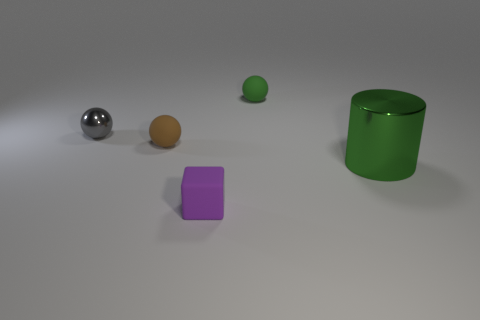There is a tiny matte ball that is behind the metal sphere; does it have the same color as the metallic object right of the small purple matte cube?
Keep it short and to the point. Yes. How many big green cylinders are in front of the small matte object in front of the big green metal object?
Your response must be concise. 0. How many rubber things are either blue cylinders or tiny cubes?
Ensure brevity in your answer.  1. Is there a small brown ball that has the same material as the block?
Offer a terse response. Yes. How many objects are either things behind the tiny cube or metal objects that are to the left of the tiny green matte thing?
Ensure brevity in your answer.  4. Is the color of the tiny rubber sphere that is behind the tiny brown rubber thing the same as the large metal thing?
Offer a very short reply. Yes. How many other things are there of the same color as the metal cylinder?
Provide a succinct answer. 1. What is the small gray ball made of?
Give a very brief answer. Metal. Is the size of the rubber sphere in front of the gray object the same as the tiny green object?
Offer a terse response. Yes. Is there any other thing that is the same size as the brown object?
Give a very brief answer. Yes. 